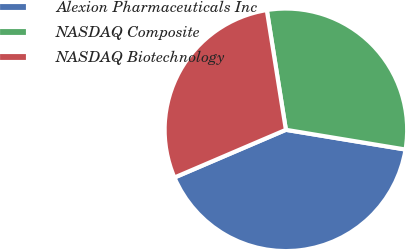Convert chart to OTSL. <chart><loc_0><loc_0><loc_500><loc_500><pie_chart><fcel>Alexion Pharmaceuticals Inc<fcel>NASDAQ Composite<fcel>NASDAQ Biotechnology<nl><fcel>40.96%<fcel>30.12%<fcel>28.92%<nl></chart> 